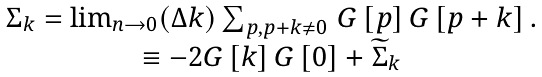<formula> <loc_0><loc_0><loc_500><loc_500>\begin{array} { c } \Sigma _ { k } = \lim _ { n \rightarrow 0 } ( \Delta k ) \sum _ { p , p + k \neq 0 } \, G \left [ { p } \right ] G \left [ { p + k } \right ] . \\ \equiv - 2 G \left [ { k } \right ] G \left [ { 0 } \right ] + \widetilde { \Sigma } _ { k } \end{array}</formula> 